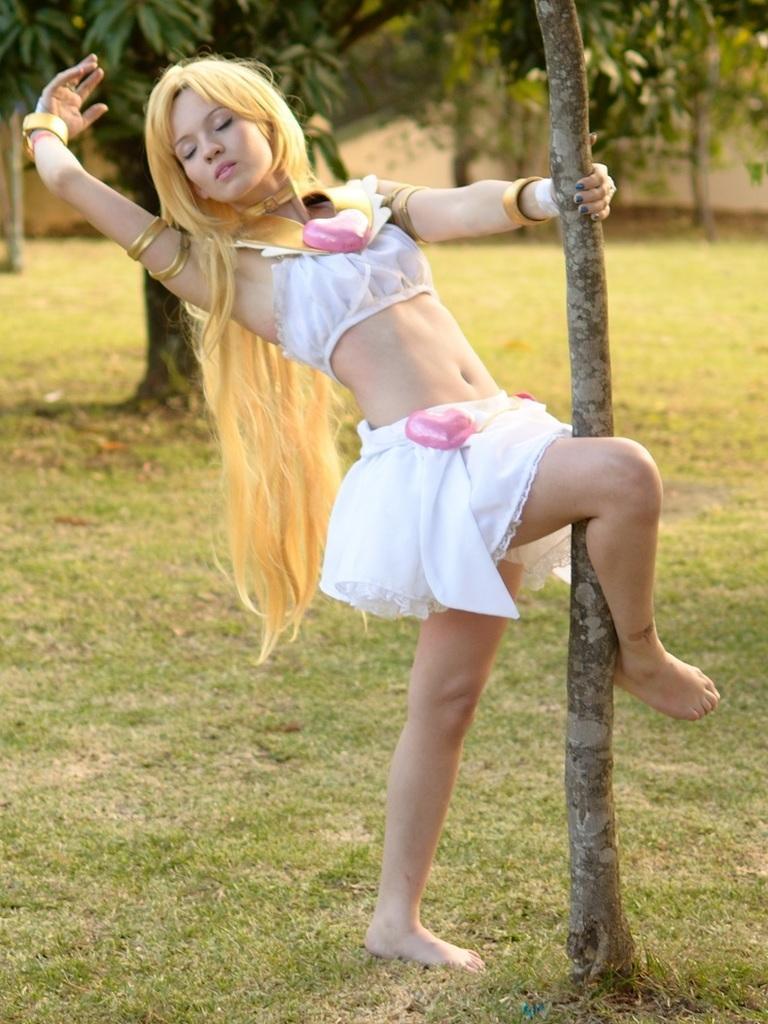In one or two sentences, can you explain what this image depicts? In the center of the image we can see a lady. In the background there are trees. At the bottom there is grass. 